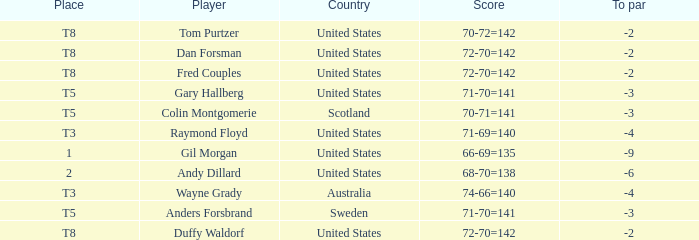What is the To par of the Player with a Score of 70-71=141? -3.0. 